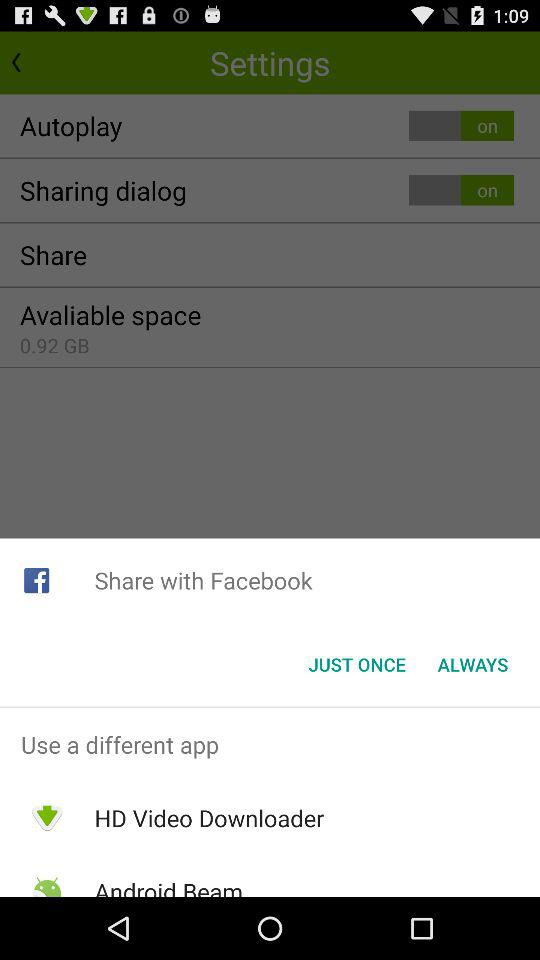What is the status of the "Autoplay" setting? The status is "on". 